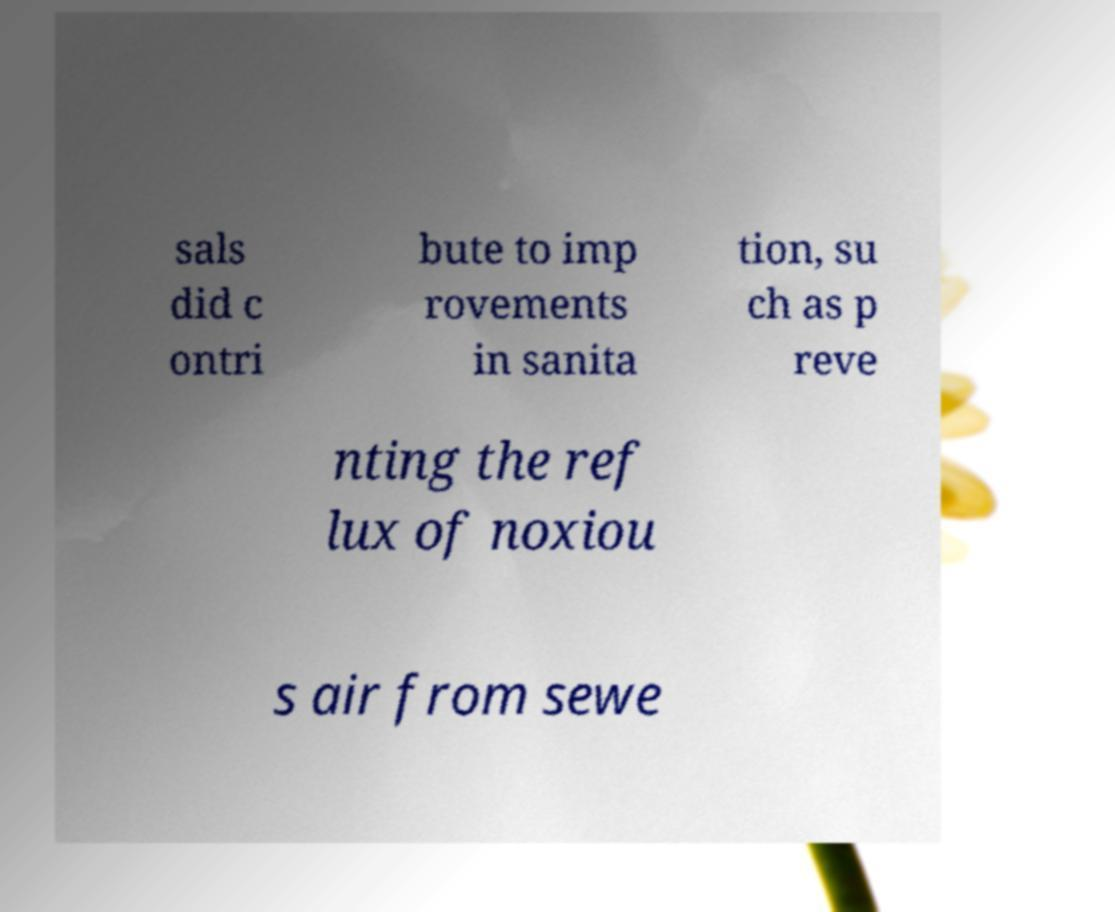Please read and relay the text visible in this image. What does it say? sals did c ontri bute to imp rovements in sanita tion, su ch as p reve nting the ref lux of noxiou s air from sewe 